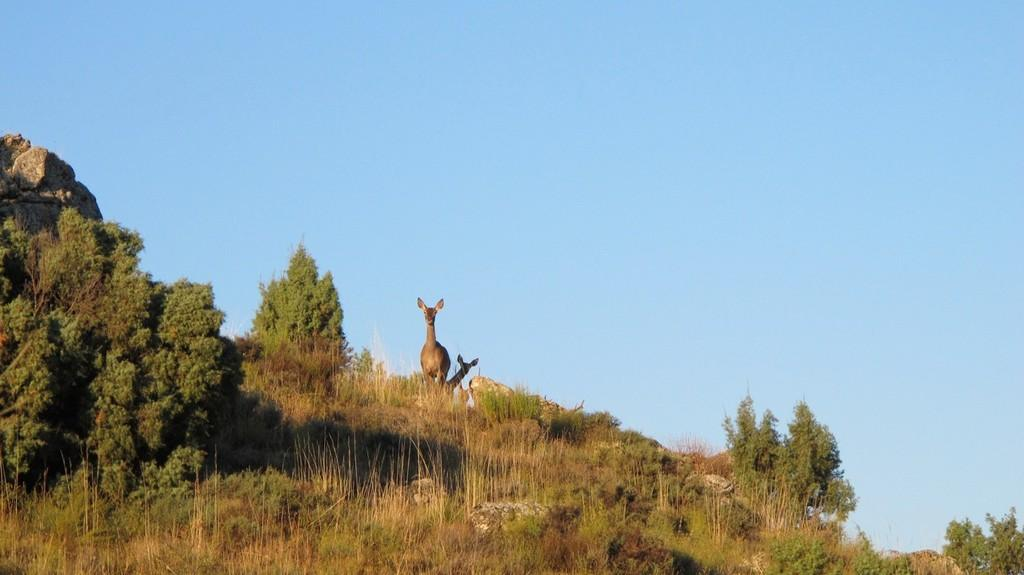What can be seen in the center of the image? There are two animals in the center of the image. What type of natural elements are present in the image? There are trees, plants, and rocks in the image. What is visible at the top of the image? The sky is visible at the top of the image. What letters are used to spell the title of the image? There is no title present in the image, so it is not possible to determine which letters might be used. Can you tell me how many times the animals sneeze in the image? There is no indication in the image that the animals are sneezing, so it cannot be determined from the picture. 